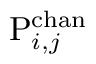<formula> <loc_0><loc_0><loc_500><loc_500>P _ { i , j } ^ { c h a n }</formula> 